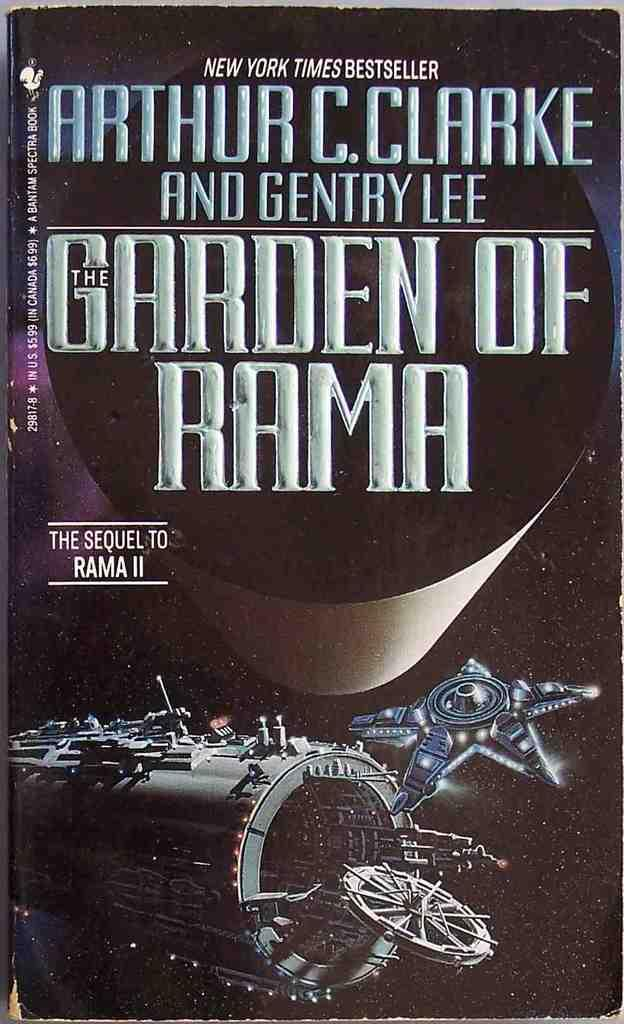Provide a one-sentence caption for the provided image. The front cover of the book Garden of Rama by Arthur C. Clarke. 